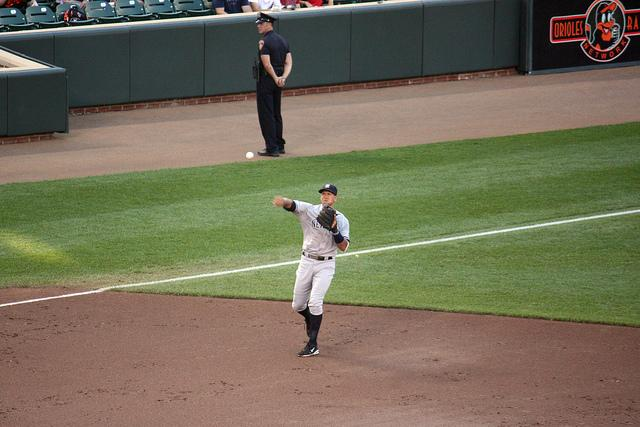What profession is the man facing the crowd? Please explain your reasoning. police officer. The man is wearing a blue uniform and is carrying a weapon. 